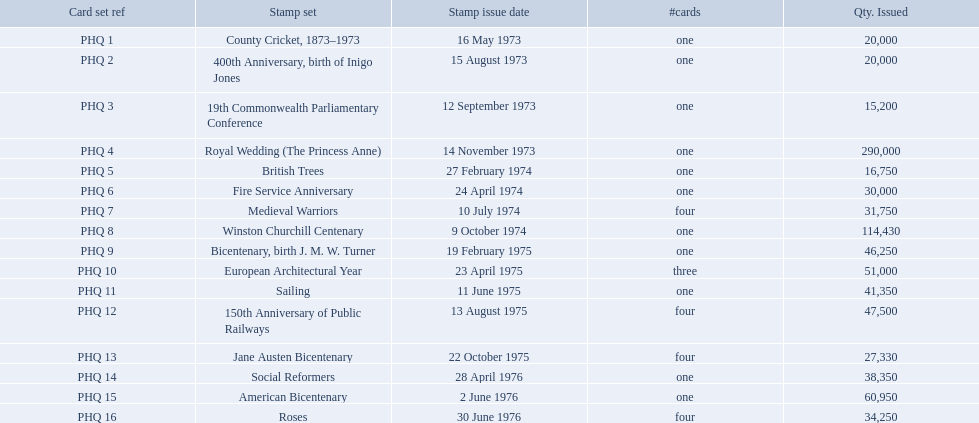Which stamp sets had three or more cards? Medieval Warriors, European Architectural Year, 150th Anniversary of Public Railways, Jane Austen Bicentenary, Roses. Of those, which one only has three cards? European Architectural Year. What are all of the stamp sets? County Cricket, 1873–1973, 400th Anniversary, birth of Inigo Jones, 19th Commonwealth Parliamentary Conference, Royal Wedding (The Princess Anne), British Trees, Fire Service Anniversary, Medieval Warriors, Winston Churchill Centenary, Bicentenary, birth J. M. W. Turner, European Architectural Year, Sailing, 150th Anniversary of Public Railways, Jane Austen Bicentenary, Social Reformers, American Bicentenary, Roses. Which of these sets has three cards in it? European Architectural Year. 